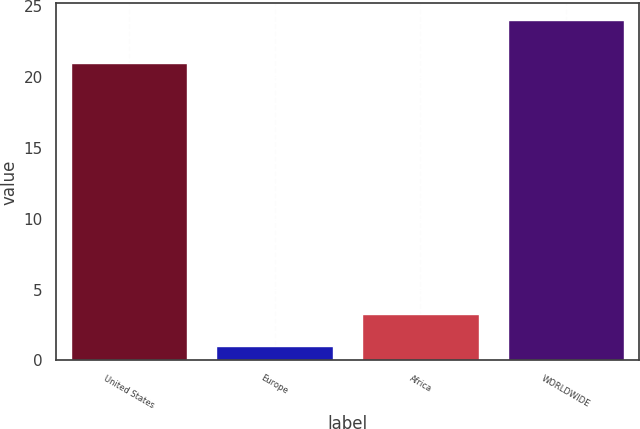<chart> <loc_0><loc_0><loc_500><loc_500><bar_chart><fcel>United States<fcel>Europe<fcel>Africa<fcel>WORLDWIDE<nl><fcel>21<fcel>1<fcel>3.3<fcel>24<nl></chart> 